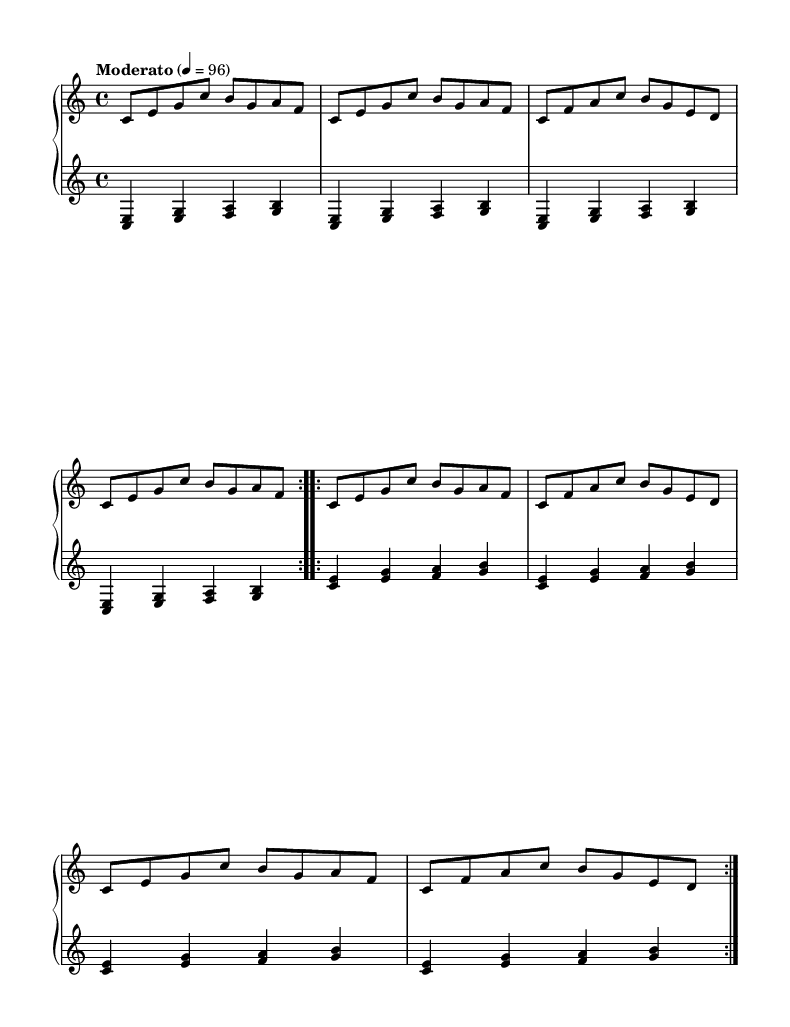What is the key signature of this music? The key signature is indicated at the beginning of the staff and is C major, which has no sharps or flats.
Answer: C major What is the time signature of this music? The time signature is found right after the key signature, indicating 4 beats per measure, commonly indicated as 4/4.
Answer: 4/4 What is the tempo marking for this piece? The tempo marking is specified in Italian as "Moderato," indicating a moderate speed, with a metronome marking of 96 beats per minute.
Answer: Moderato How many times does the upper staff section repeat? The upper staff has sections marked with repeat signs, indicating it is played twice for the first and second sections.
Answer: 2 What type of chords are predominantly used in the lower staff? The lower staff primarily uses first inversion triads, which feature the primary note of each triad in the base and the other chords stacked above it.
Answer: First inversion triads What is the dynamic level indicated for this composition? The score does not show any specific dynamic markings, implying that it is played at a medium dynamic level throughout unless otherwise noted by the performer.
Answer: Medium 